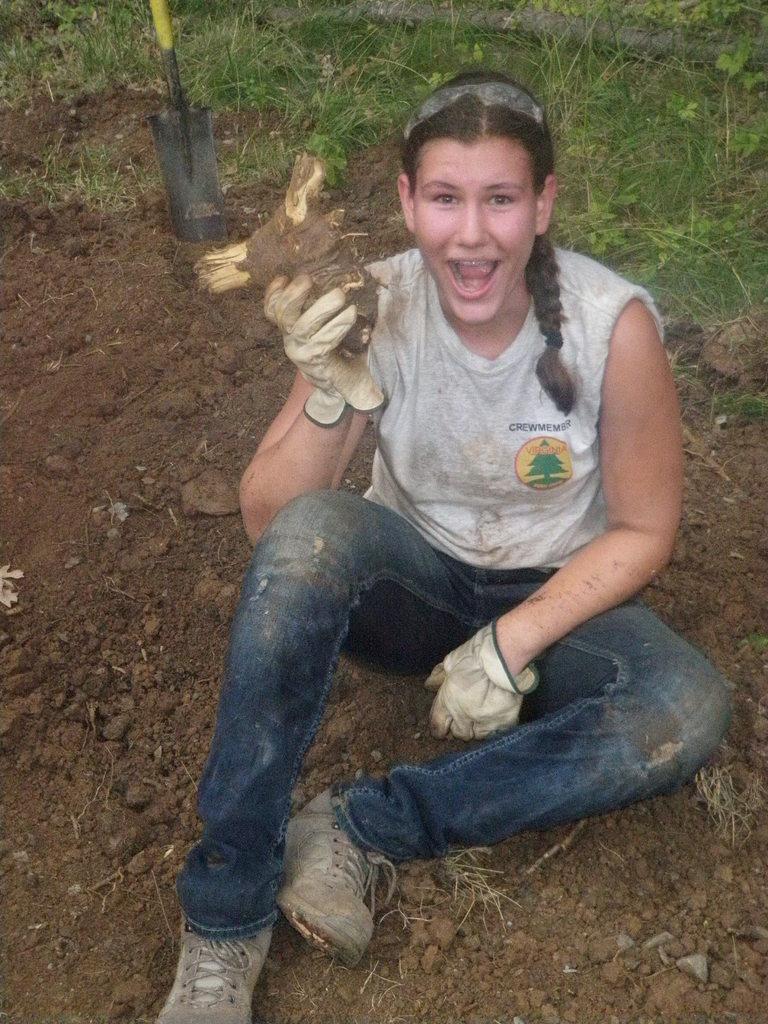Describe this image in one or two sentences. In this image in the front there is a woman sitting on ground and holding an object and having some expression on her face. In the background there is grass on the ground and there is an object which is black and yellow in colour. 